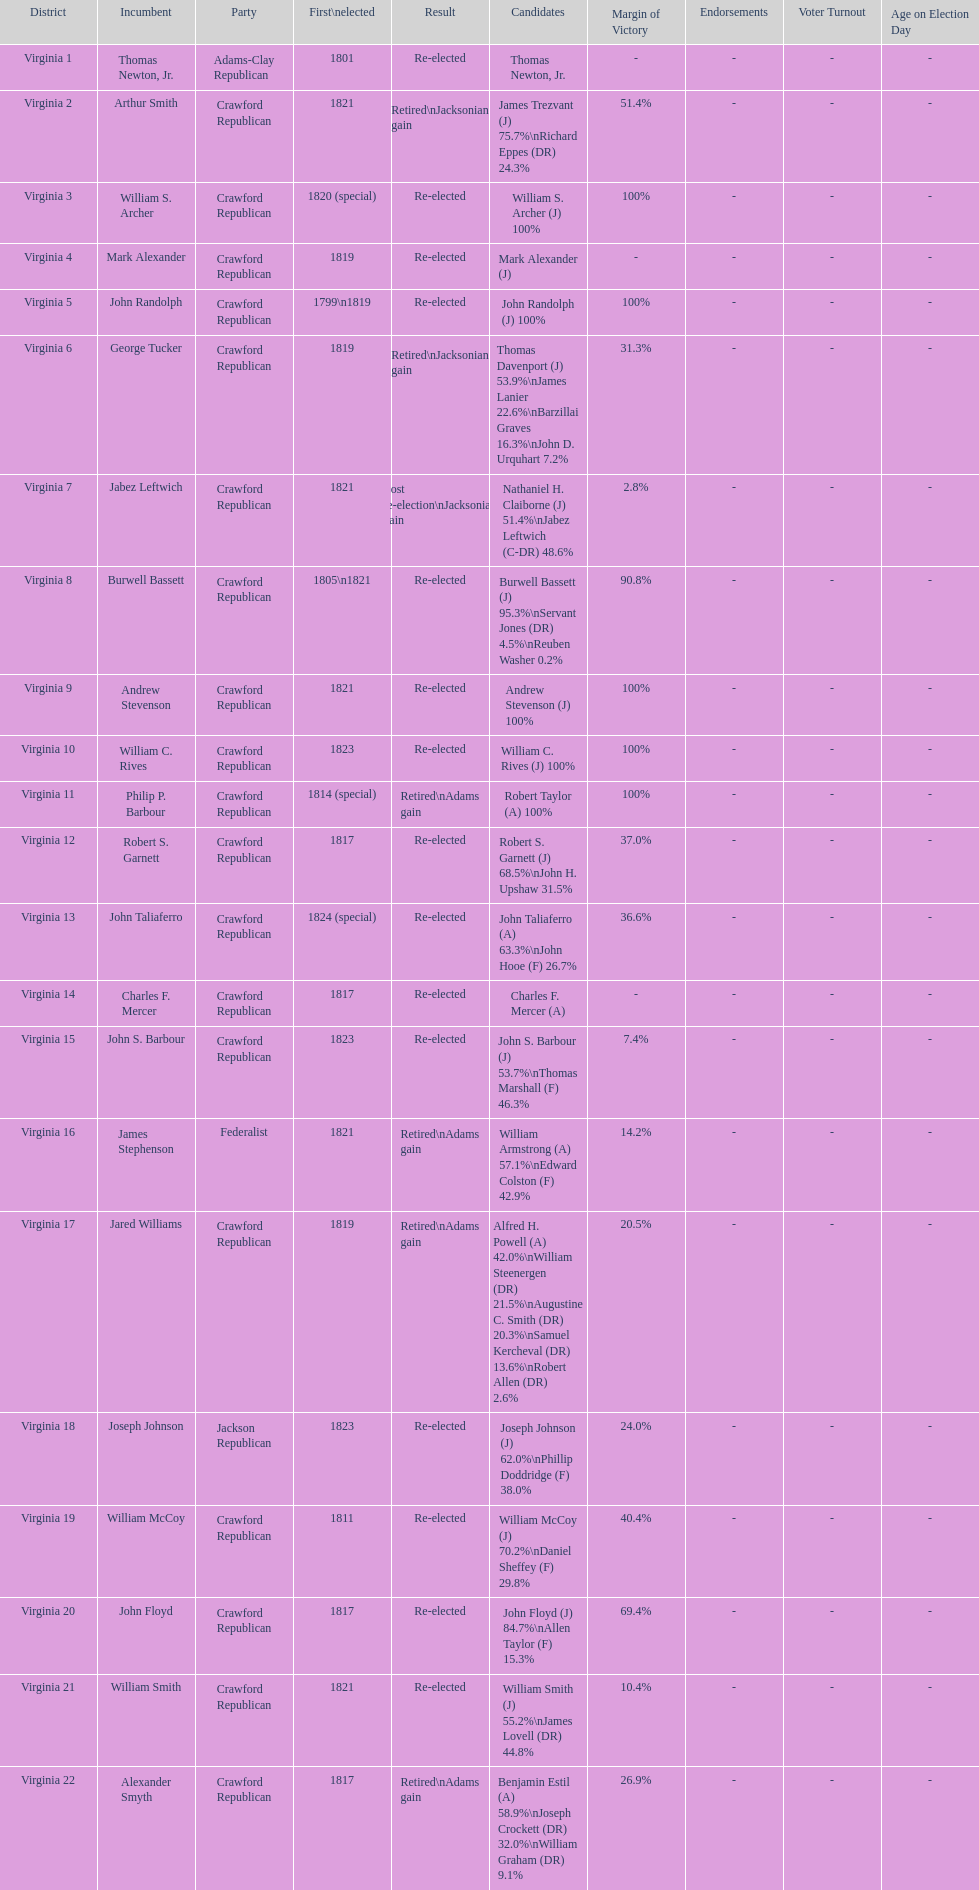How many districts are there in virginia? 22. 